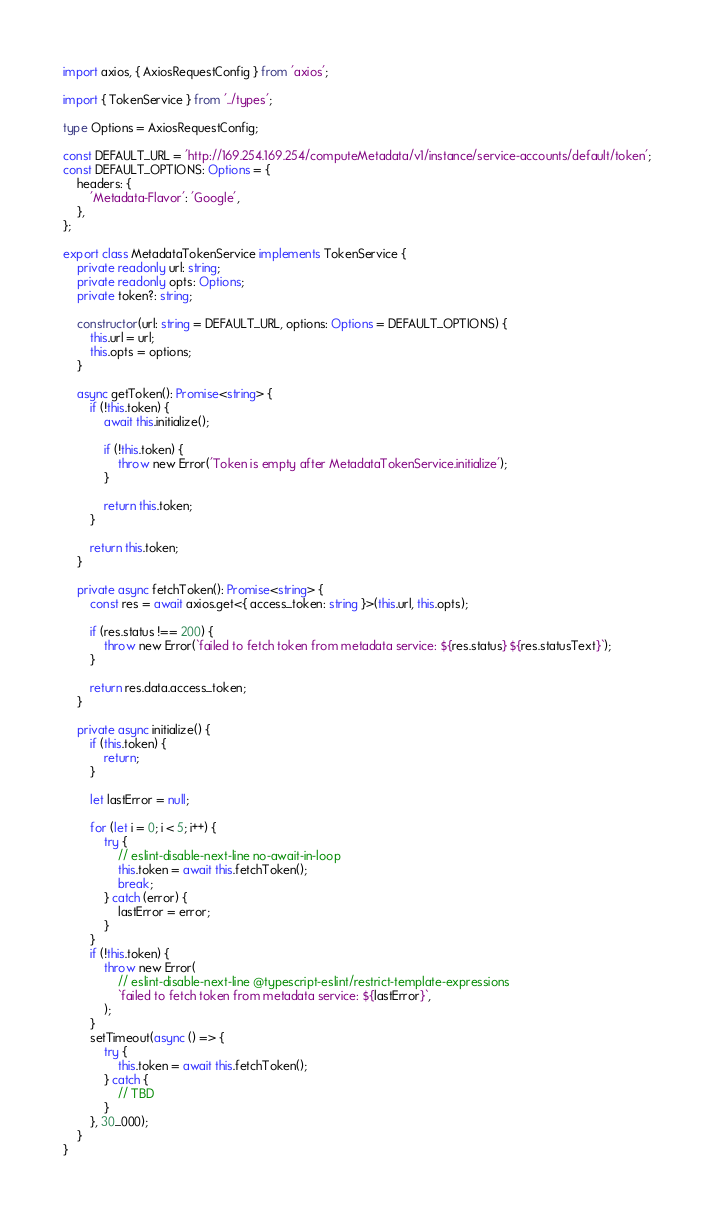Convert code to text. <code><loc_0><loc_0><loc_500><loc_500><_TypeScript_>import axios, { AxiosRequestConfig } from 'axios';

import { TokenService } from '../types';

type Options = AxiosRequestConfig;

const DEFAULT_URL = 'http://169.254.169.254/computeMetadata/v1/instance/service-accounts/default/token';
const DEFAULT_OPTIONS: Options = {
    headers: {
        'Metadata-Flavor': 'Google',
    },
};

export class MetadataTokenService implements TokenService {
    private readonly url: string;
    private readonly opts: Options;
    private token?: string;

    constructor(url: string = DEFAULT_URL, options: Options = DEFAULT_OPTIONS) {
        this.url = url;
        this.opts = options;
    }

    async getToken(): Promise<string> {
        if (!this.token) {
            await this.initialize();

            if (!this.token) {
                throw new Error('Token is empty after MetadataTokenService.initialize');
            }

            return this.token;
        }

        return this.token;
    }

    private async fetchToken(): Promise<string> {
        const res = await axios.get<{ access_token: string }>(this.url, this.opts);

        if (res.status !== 200) {
            throw new Error(`failed to fetch token from metadata service: ${res.status} ${res.statusText}`);
        }

        return res.data.access_token;
    }

    private async initialize() {
        if (this.token) {
            return;
        }

        let lastError = null;

        for (let i = 0; i < 5; i++) {
            try {
                // eslint-disable-next-line no-await-in-loop
                this.token = await this.fetchToken();
                break;
            } catch (error) {
                lastError = error;
            }
        }
        if (!this.token) {
            throw new Error(
                // eslint-disable-next-line @typescript-eslint/restrict-template-expressions
                `failed to fetch token from metadata service: ${lastError}`,
            );
        }
        setTimeout(async () => {
            try {
                this.token = await this.fetchToken();
            } catch {
                // TBD
            }
        }, 30_000);
    }
}
</code> 